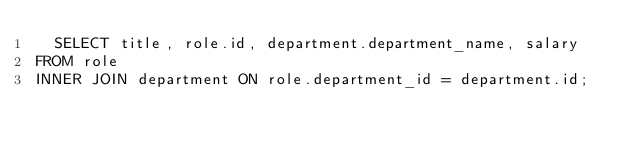<code> <loc_0><loc_0><loc_500><loc_500><_SQL_>  SELECT title, role.id, department.department_name, salary
FROM role
INNER JOIN department ON role.department_id = department.id;</code> 